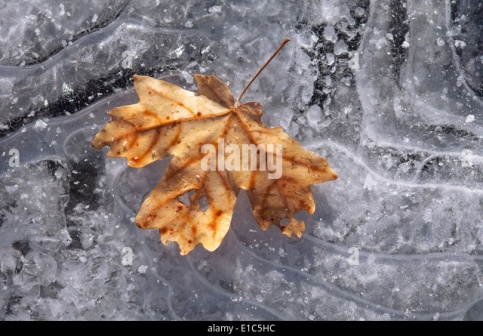Describe the following image. In this image, we witness a serene winter scene dominated by a single, brown maple leaf, resting gently on a frozen surface. The leaf is positioned towards the center, with its stem pointing diagonally towards the top-left corner. The once-vibrant leaf now bears the marks of time, with its edges slightly curled and its color transitioning from the bright hues of autumn to the muted tones of winter.

Beneath the leaf, the frozen surface is mesmerizing, displaying an array of intricate ice patterns. The ice varies in appearance, with patches that are opaque white, interspersed with more transparent sections, reflecting light in subtle ways that reveal varying depths and textures. No other objects or distractions are present in the image, emphasizing the quiet and tranquil beauty of this simple natural scene.

Overall, the image exudes a peaceful and contemplative atmosphere, capturing a moment of stillness and reflection as the leaf lies dormant on the icy surface, symbolizing the passage from autumn to winter. 